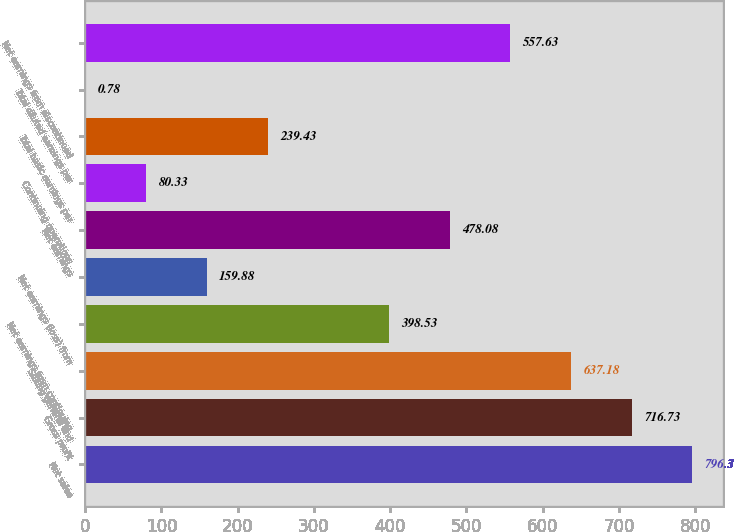Convert chart. <chart><loc_0><loc_0><loc_500><loc_500><bar_chart><fcel>Net sales<fcel>Gross profit<fcel>Selling general and<fcel>Net earnings from continuing<fcel>Net earnings (loss) from<fcel>Net earnings<fcel>Continuing operations<fcel>Total basic earnings per<fcel>Total diluted earnings per<fcel>Net earnings from discontinued<nl><fcel>796.3<fcel>716.73<fcel>637.18<fcel>398.53<fcel>159.88<fcel>478.08<fcel>80.33<fcel>239.43<fcel>0.78<fcel>557.63<nl></chart> 